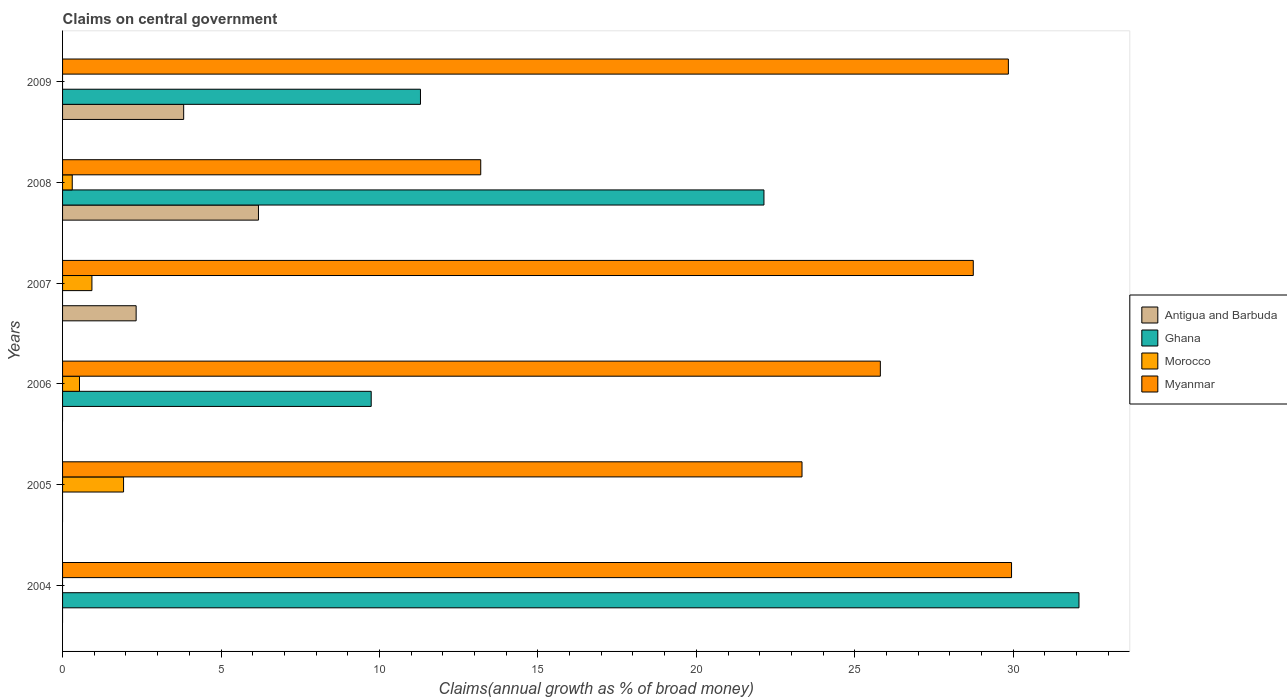How many different coloured bars are there?
Make the answer very short. 4. How many groups of bars are there?
Ensure brevity in your answer.  6. Are the number of bars on each tick of the Y-axis equal?
Your response must be concise. No. How many bars are there on the 5th tick from the top?
Your response must be concise. 2. What is the label of the 1st group of bars from the top?
Your answer should be compact. 2009. In how many cases, is the number of bars for a given year not equal to the number of legend labels?
Your answer should be compact. 5. What is the percentage of broad money claimed on centeral government in Antigua and Barbuda in 2008?
Ensure brevity in your answer.  6.18. Across all years, what is the maximum percentage of broad money claimed on centeral government in Morocco?
Keep it short and to the point. 1.92. Across all years, what is the minimum percentage of broad money claimed on centeral government in Antigua and Barbuda?
Ensure brevity in your answer.  0. In which year was the percentage of broad money claimed on centeral government in Antigua and Barbuda maximum?
Your response must be concise. 2008. What is the total percentage of broad money claimed on centeral government in Morocco in the graph?
Offer a terse response. 3.69. What is the difference between the percentage of broad money claimed on centeral government in Ghana in 2008 and that in 2009?
Give a very brief answer. 10.84. What is the difference between the percentage of broad money claimed on centeral government in Morocco in 2009 and the percentage of broad money claimed on centeral government in Myanmar in 2007?
Provide a succinct answer. -28.74. What is the average percentage of broad money claimed on centeral government in Myanmar per year?
Keep it short and to the point. 25.15. In the year 2008, what is the difference between the percentage of broad money claimed on centeral government in Myanmar and percentage of broad money claimed on centeral government in Ghana?
Provide a short and direct response. -8.94. In how many years, is the percentage of broad money claimed on centeral government in Antigua and Barbuda greater than 3 %?
Provide a short and direct response. 2. What is the ratio of the percentage of broad money claimed on centeral government in Antigua and Barbuda in 2007 to that in 2008?
Ensure brevity in your answer.  0.38. What is the difference between the highest and the second highest percentage of broad money claimed on centeral government in Antigua and Barbuda?
Offer a very short reply. 2.36. What is the difference between the highest and the lowest percentage of broad money claimed on centeral government in Antigua and Barbuda?
Keep it short and to the point. 6.18. Is it the case that in every year, the sum of the percentage of broad money claimed on centeral government in Morocco and percentage of broad money claimed on centeral government in Myanmar is greater than the sum of percentage of broad money claimed on centeral government in Ghana and percentage of broad money claimed on centeral government in Antigua and Barbuda?
Make the answer very short. No. Are all the bars in the graph horizontal?
Offer a very short reply. Yes. How many years are there in the graph?
Offer a very short reply. 6. What is the difference between two consecutive major ticks on the X-axis?
Your response must be concise. 5. Are the values on the major ticks of X-axis written in scientific E-notation?
Keep it short and to the point. No. Does the graph contain any zero values?
Your answer should be compact. Yes. Where does the legend appear in the graph?
Offer a terse response. Center right. How are the legend labels stacked?
Ensure brevity in your answer.  Vertical. What is the title of the graph?
Your answer should be very brief. Claims on central government. What is the label or title of the X-axis?
Your answer should be very brief. Claims(annual growth as % of broad money). What is the Claims(annual growth as % of broad money) in Ghana in 2004?
Offer a very short reply. 32.08. What is the Claims(annual growth as % of broad money) of Myanmar in 2004?
Offer a terse response. 29.95. What is the Claims(annual growth as % of broad money) in Morocco in 2005?
Offer a terse response. 1.92. What is the Claims(annual growth as % of broad money) of Myanmar in 2005?
Ensure brevity in your answer.  23.34. What is the Claims(annual growth as % of broad money) in Antigua and Barbuda in 2006?
Offer a terse response. 0. What is the Claims(annual growth as % of broad money) of Ghana in 2006?
Your answer should be very brief. 9.74. What is the Claims(annual growth as % of broad money) in Morocco in 2006?
Offer a very short reply. 0.53. What is the Claims(annual growth as % of broad money) of Myanmar in 2006?
Keep it short and to the point. 25.81. What is the Claims(annual growth as % of broad money) in Antigua and Barbuda in 2007?
Your answer should be very brief. 2.32. What is the Claims(annual growth as % of broad money) of Morocco in 2007?
Your answer should be very brief. 0.93. What is the Claims(annual growth as % of broad money) of Myanmar in 2007?
Your response must be concise. 28.74. What is the Claims(annual growth as % of broad money) in Antigua and Barbuda in 2008?
Provide a short and direct response. 6.18. What is the Claims(annual growth as % of broad money) of Ghana in 2008?
Your answer should be very brief. 22.13. What is the Claims(annual growth as % of broad money) of Morocco in 2008?
Offer a very short reply. 0.31. What is the Claims(annual growth as % of broad money) of Myanmar in 2008?
Keep it short and to the point. 13.2. What is the Claims(annual growth as % of broad money) of Antigua and Barbuda in 2009?
Offer a terse response. 3.82. What is the Claims(annual growth as % of broad money) of Ghana in 2009?
Keep it short and to the point. 11.29. What is the Claims(annual growth as % of broad money) of Morocco in 2009?
Make the answer very short. 0. What is the Claims(annual growth as % of broad money) in Myanmar in 2009?
Keep it short and to the point. 29.85. Across all years, what is the maximum Claims(annual growth as % of broad money) of Antigua and Barbuda?
Offer a terse response. 6.18. Across all years, what is the maximum Claims(annual growth as % of broad money) in Ghana?
Keep it short and to the point. 32.08. Across all years, what is the maximum Claims(annual growth as % of broad money) of Morocco?
Offer a very short reply. 1.92. Across all years, what is the maximum Claims(annual growth as % of broad money) of Myanmar?
Your answer should be very brief. 29.95. Across all years, what is the minimum Claims(annual growth as % of broad money) of Antigua and Barbuda?
Give a very brief answer. 0. Across all years, what is the minimum Claims(annual growth as % of broad money) in Myanmar?
Your answer should be very brief. 13.2. What is the total Claims(annual growth as % of broad money) in Antigua and Barbuda in the graph?
Provide a short and direct response. 12.33. What is the total Claims(annual growth as % of broad money) of Ghana in the graph?
Ensure brevity in your answer.  75.25. What is the total Claims(annual growth as % of broad money) in Morocco in the graph?
Provide a succinct answer. 3.69. What is the total Claims(annual growth as % of broad money) of Myanmar in the graph?
Provide a short and direct response. 150.88. What is the difference between the Claims(annual growth as % of broad money) in Myanmar in 2004 and that in 2005?
Provide a succinct answer. 6.61. What is the difference between the Claims(annual growth as % of broad money) of Ghana in 2004 and that in 2006?
Your answer should be very brief. 22.34. What is the difference between the Claims(annual growth as % of broad money) of Myanmar in 2004 and that in 2006?
Keep it short and to the point. 4.14. What is the difference between the Claims(annual growth as % of broad money) in Myanmar in 2004 and that in 2007?
Give a very brief answer. 1.21. What is the difference between the Claims(annual growth as % of broad money) of Ghana in 2004 and that in 2008?
Your response must be concise. 9.94. What is the difference between the Claims(annual growth as % of broad money) in Myanmar in 2004 and that in 2008?
Offer a terse response. 16.75. What is the difference between the Claims(annual growth as % of broad money) in Ghana in 2004 and that in 2009?
Give a very brief answer. 20.78. What is the difference between the Claims(annual growth as % of broad money) of Myanmar in 2004 and that in 2009?
Ensure brevity in your answer.  0.1. What is the difference between the Claims(annual growth as % of broad money) of Morocco in 2005 and that in 2006?
Offer a terse response. 1.39. What is the difference between the Claims(annual growth as % of broad money) of Myanmar in 2005 and that in 2006?
Make the answer very short. -2.47. What is the difference between the Claims(annual growth as % of broad money) of Myanmar in 2005 and that in 2007?
Keep it short and to the point. -5.41. What is the difference between the Claims(annual growth as % of broad money) of Morocco in 2005 and that in 2008?
Your response must be concise. 1.62. What is the difference between the Claims(annual growth as % of broad money) in Myanmar in 2005 and that in 2008?
Give a very brief answer. 10.14. What is the difference between the Claims(annual growth as % of broad money) of Myanmar in 2005 and that in 2009?
Your answer should be compact. -6.51. What is the difference between the Claims(annual growth as % of broad money) in Morocco in 2006 and that in 2007?
Offer a very short reply. -0.39. What is the difference between the Claims(annual growth as % of broad money) in Myanmar in 2006 and that in 2007?
Your answer should be compact. -2.93. What is the difference between the Claims(annual growth as % of broad money) in Ghana in 2006 and that in 2008?
Your answer should be very brief. -12.39. What is the difference between the Claims(annual growth as % of broad money) in Morocco in 2006 and that in 2008?
Offer a terse response. 0.23. What is the difference between the Claims(annual growth as % of broad money) of Myanmar in 2006 and that in 2008?
Keep it short and to the point. 12.61. What is the difference between the Claims(annual growth as % of broad money) of Ghana in 2006 and that in 2009?
Keep it short and to the point. -1.55. What is the difference between the Claims(annual growth as % of broad money) of Myanmar in 2006 and that in 2009?
Offer a terse response. -4.04. What is the difference between the Claims(annual growth as % of broad money) in Antigua and Barbuda in 2007 and that in 2008?
Your answer should be compact. -3.86. What is the difference between the Claims(annual growth as % of broad money) in Morocco in 2007 and that in 2008?
Your response must be concise. 0.62. What is the difference between the Claims(annual growth as % of broad money) in Myanmar in 2007 and that in 2008?
Ensure brevity in your answer.  15.54. What is the difference between the Claims(annual growth as % of broad money) of Myanmar in 2007 and that in 2009?
Provide a short and direct response. -1.11. What is the difference between the Claims(annual growth as % of broad money) of Antigua and Barbuda in 2008 and that in 2009?
Make the answer very short. 2.36. What is the difference between the Claims(annual growth as % of broad money) in Ghana in 2008 and that in 2009?
Provide a short and direct response. 10.84. What is the difference between the Claims(annual growth as % of broad money) of Myanmar in 2008 and that in 2009?
Your response must be concise. -16.65. What is the difference between the Claims(annual growth as % of broad money) of Ghana in 2004 and the Claims(annual growth as % of broad money) of Morocco in 2005?
Make the answer very short. 30.15. What is the difference between the Claims(annual growth as % of broad money) in Ghana in 2004 and the Claims(annual growth as % of broad money) in Myanmar in 2005?
Provide a succinct answer. 8.74. What is the difference between the Claims(annual growth as % of broad money) of Ghana in 2004 and the Claims(annual growth as % of broad money) of Morocco in 2006?
Ensure brevity in your answer.  31.54. What is the difference between the Claims(annual growth as % of broad money) of Ghana in 2004 and the Claims(annual growth as % of broad money) of Myanmar in 2006?
Provide a short and direct response. 6.27. What is the difference between the Claims(annual growth as % of broad money) in Ghana in 2004 and the Claims(annual growth as % of broad money) in Morocco in 2007?
Offer a very short reply. 31.15. What is the difference between the Claims(annual growth as % of broad money) of Ghana in 2004 and the Claims(annual growth as % of broad money) of Myanmar in 2007?
Keep it short and to the point. 3.34. What is the difference between the Claims(annual growth as % of broad money) in Ghana in 2004 and the Claims(annual growth as % of broad money) in Morocco in 2008?
Provide a short and direct response. 31.77. What is the difference between the Claims(annual growth as % of broad money) of Ghana in 2004 and the Claims(annual growth as % of broad money) of Myanmar in 2008?
Provide a succinct answer. 18.88. What is the difference between the Claims(annual growth as % of broad money) in Ghana in 2004 and the Claims(annual growth as % of broad money) in Myanmar in 2009?
Your answer should be compact. 2.23. What is the difference between the Claims(annual growth as % of broad money) in Morocco in 2005 and the Claims(annual growth as % of broad money) in Myanmar in 2006?
Make the answer very short. -23.88. What is the difference between the Claims(annual growth as % of broad money) in Morocco in 2005 and the Claims(annual growth as % of broad money) in Myanmar in 2007?
Give a very brief answer. -26.82. What is the difference between the Claims(annual growth as % of broad money) in Morocco in 2005 and the Claims(annual growth as % of broad money) in Myanmar in 2008?
Give a very brief answer. -11.27. What is the difference between the Claims(annual growth as % of broad money) of Morocco in 2005 and the Claims(annual growth as % of broad money) of Myanmar in 2009?
Provide a succinct answer. -27.92. What is the difference between the Claims(annual growth as % of broad money) of Ghana in 2006 and the Claims(annual growth as % of broad money) of Morocco in 2007?
Ensure brevity in your answer.  8.81. What is the difference between the Claims(annual growth as % of broad money) in Ghana in 2006 and the Claims(annual growth as % of broad money) in Myanmar in 2007?
Make the answer very short. -19. What is the difference between the Claims(annual growth as % of broad money) of Morocco in 2006 and the Claims(annual growth as % of broad money) of Myanmar in 2007?
Give a very brief answer. -28.21. What is the difference between the Claims(annual growth as % of broad money) in Ghana in 2006 and the Claims(annual growth as % of broad money) in Morocco in 2008?
Offer a very short reply. 9.43. What is the difference between the Claims(annual growth as % of broad money) of Ghana in 2006 and the Claims(annual growth as % of broad money) of Myanmar in 2008?
Your answer should be compact. -3.46. What is the difference between the Claims(annual growth as % of broad money) in Morocco in 2006 and the Claims(annual growth as % of broad money) in Myanmar in 2008?
Keep it short and to the point. -12.66. What is the difference between the Claims(annual growth as % of broad money) of Ghana in 2006 and the Claims(annual growth as % of broad money) of Myanmar in 2009?
Your response must be concise. -20.11. What is the difference between the Claims(annual growth as % of broad money) of Morocco in 2006 and the Claims(annual growth as % of broad money) of Myanmar in 2009?
Give a very brief answer. -29.31. What is the difference between the Claims(annual growth as % of broad money) in Antigua and Barbuda in 2007 and the Claims(annual growth as % of broad money) in Ghana in 2008?
Keep it short and to the point. -19.81. What is the difference between the Claims(annual growth as % of broad money) of Antigua and Barbuda in 2007 and the Claims(annual growth as % of broad money) of Morocco in 2008?
Your answer should be very brief. 2.02. What is the difference between the Claims(annual growth as % of broad money) in Antigua and Barbuda in 2007 and the Claims(annual growth as % of broad money) in Myanmar in 2008?
Offer a very short reply. -10.87. What is the difference between the Claims(annual growth as % of broad money) in Morocco in 2007 and the Claims(annual growth as % of broad money) in Myanmar in 2008?
Offer a very short reply. -12.27. What is the difference between the Claims(annual growth as % of broad money) of Antigua and Barbuda in 2007 and the Claims(annual growth as % of broad money) of Ghana in 2009?
Offer a terse response. -8.97. What is the difference between the Claims(annual growth as % of broad money) of Antigua and Barbuda in 2007 and the Claims(annual growth as % of broad money) of Myanmar in 2009?
Offer a terse response. -27.53. What is the difference between the Claims(annual growth as % of broad money) of Morocco in 2007 and the Claims(annual growth as % of broad money) of Myanmar in 2009?
Keep it short and to the point. -28.92. What is the difference between the Claims(annual growth as % of broad money) of Antigua and Barbuda in 2008 and the Claims(annual growth as % of broad money) of Ghana in 2009?
Ensure brevity in your answer.  -5.11. What is the difference between the Claims(annual growth as % of broad money) of Antigua and Barbuda in 2008 and the Claims(annual growth as % of broad money) of Myanmar in 2009?
Make the answer very short. -23.67. What is the difference between the Claims(annual growth as % of broad money) in Ghana in 2008 and the Claims(annual growth as % of broad money) in Myanmar in 2009?
Your answer should be very brief. -7.71. What is the difference between the Claims(annual growth as % of broad money) in Morocco in 2008 and the Claims(annual growth as % of broad money) in Myanmar in 2009?
Keep it short and to the point. -29.54. What is the average Claims(annual growth as % of broad money) of Antigua and Barbuda per year?
Your answer should be compact. 2.05. What is the average Claims(annual growth as % of broad money) in Ghana per year?
Provide a succinct answer. 12.54. What is the average Claims(annual growth as % of broad money) of Morocco per year?
Your answer should be compact. 0.62. What is the average Claims(annual growth as % of broad money) in Myanmar per year?
Provide a short and direct response. 25.15. In the year 2004, what is the difference between the Claims(annual growth as % of broad money) in Ghana and Claims(annual growth as % of broad money) in Myanmar?
Your answer should be very brief. 2.13. In the year 2005, what is the difference between the Claims(annual growth as % of broad money) of Morocco and Claims(annual growth as % of broad money) of Myanmar?
Your response must be concise. -21.41. In the year 2006, what is the difference between the Claims(annual growth as % of broad money) of Ghana and Claims(annual growth as % of broad money) of Morocco?
Make the answer very short. 9.21. In the year 2006, what is the difference between the Claims(annual growth as % of broad money) in Ghana and Claims(annual growth as % of broad money) in Myanmar?
Your response must be concise. -16.07. In the year 2006, what is the difference between the Claims(annual growth as % of broad money) of Morocco and Claims(annual growth as % of broad money) of Myanmar?
Give a very brief answer. -25.27. In the year 2007, what is the difference between the Claims(annual growth as % of broad money) in Antigua and Barbuda and Claims(annual growth as % of broad money) in Morocco?
Your answer should be very brief. 1.4. In the year 2007, what is the difference between the Claims(annual growth as % of broad money) in Antigua and Barbuda and Claims(annual growth as % of broad money) in Myanmar?
Offer a terse response. -26.42. In the year 2007, what is the difference between the Claims(annual growth as % of broad money) in Morocco and Claims(annual growth as % of broad money) in Myanmar?
Offer a very short reply. -27.81. In the year 2008, what is the difference between the Claims(annual growth as % of broad money) of Antigua and Barbuda and Claims(annual growth as % of broad money) of Ghana?
Keep it short and to the point. -15.95. In the year 2008, what is the difference between the Claims(annual growth as % of broad money) of Antigua and Barbuda and Claims(annual growth as % of broad money) of Morocco?
Give a very brief answer. 5.88. In the year 2008, what is the difference between the Claims(annual growth as % of broad money) of Antigua and Barbuda and Claims(annual growth as % of broad money) of Myanmar?
Offer a very short reply. -7.01. In the year 2008, what is the difference between the Claims(annual growth as % of broad money) of Ghana and Claims(annual growth as % of broad money) of Morocco?
Keep it short and to the point. 21.83. In the year 2008, what is the difference between the Claims(annual growth as % of broad money) in Ghana and Claims(annual growth as % of broad money) in Myanmar?
Your answer should be compact. 8.94. In the year 2008, what is the difference between the Claims(annual growth as % of broad money) of Morocco and Claims(annual growth as % of broad money) of Myanmar?
Provide a short and direct response. -12.89. In the year 2009, what is the difference between the Claims(annual growth as % of broad money) of Antigua and Barbuda and Claims(annual growth as % of broad money) of Ghana?
Ensure brevity in your answer.  -7.47. In the year 2009, what is the difference between the Claims(annual growth as % of broad money) in Antigua and Barbuda and Claims(annual growth as % of broad money) in Myanmar?
Provide a short and direct response. -26.03. In the year 2009, what is the difference between the Claims(annual growth as % of broad money) in Ghana and Claims(annual growth as % of broad money) in Myanmar?
Keep it short and to the point. -18.55. What is the ratio of the Claims(annual growth as % of broad money) of Myanmar in 2004 to that in 2005?
Offer a very short reply. 1.28. What is the ratio of the Claims(annual growth as % of broad money) in Ghana in 2004 to that in 2006?
Provide a succinct answer. 3.29. What is the ratio of the Claims(annual growth as % of broad money) in Myanmar in 2004 to that in 2006?
Provide a short and direct response. 1.16. What is the ratio of the Claims(annual growth as % of broad money) of Myanmar in 2004 to that in 2007?
Your answer should be compact. 1.04. What is the ratio of the Claims(annual growth as % of broad money) in Ghana in 2004 to that in 2008?
Provide a succinct answer. 1.45. What is the ratio of the Claims(annual growth as % of broad money) of Myanmar in 2004 to that in 2008?
Offer a very short reply. 2.27. What is the ratio of the Claims(annual growth as % of broad money) of Ghana in 2004 to that in 2009?
Ensure brevity in your answer.  2.84. What is the ratio of the Claims(annual growth as % of broad money) of Morocco in 2005 to that in 2006?
Your answer should be compact. 3.61. What is the ratio of the Claims(annual growth as % of broad money) of Myanmar in 2005 to that in 2006?
Your answer should be compact. 0.9. What is the ratio of the Claims(annual growth as % of broad money) in Morocco in 2005 to that in 2007?
Your response must be concise. 2.08. What is the ratio of the Claims(annual growth as % of broad money) in Myanmar in 2005 to that in 2007?
Ensure brevity in your answer.  0.81. What is the ratio of the Claims(annual growth as % of broad money) in Morocco in 2005 to that in 2008?
Your response must be concise. 6.29. What is the ratio of the Claims(annual growth as % of broad money) of Myanmar in 2005 to that in 2008?
Provide a short and direct response. 1.77. What is the ratio of the Claims(annual growth as % of broad money) in Myanmar in 2005 to that in 2009?
Provide a succinct answer. 0.78. What is the ratio of the Claims(annual growth as % of broad money) of Morocco in 2006 to that in 2007?
Your response must be concise. 0.58. What is the ratio of the Claims(annual growth as % of broad money) in Myanmar in 2006 to that in 2007?
Your answer should be compact. 0.9. What is the ratio of the Claims(annual growth as % of broad money) of Ghana in 2006 to that in 2008?
Offer a very short reply. 0.44. What is the ratio of the Claims(annual growth as % of broad money) of Morocco in 2006 to that in 2008?
Ensure brevity in your answer.  1.74. What is the ratio of the Claims(annual growth as % of broad money) of Myanmar in 2006 to that in 2008?
Give a very brief answer. 1.96. What is the ratio of the Claims(annual growth as % of broad money) of Ghana in 2006 to that in 2009?
Keep it short and to the point. 0.86. What is the ratio of the Claims(annual growth as % of broad money) of Myanmar in 2006 to that in 2009?
Your response must be concise. 0.86. What is the ratio of the Claims(annual growth as % of broad money) of Antigua and Barbuda in 2007 to that in 2008?
Offer a very short reply. 0.38. What is the ratio of the Claims(annual growth as % of broad money) in Morocco in 2007 to that in 2008?
Provide a succinct answer. 3.03. What is the ratio of the Claims(annual growth as % of broad money) in Myanmar in 2007 to that in 2008?
Offer a terse response. 2.18. What is the ratio of the Claims(annual growth as % of broad money) in Antigua and Barbuda in 2007 to that in 2009?
Provide a succinct answer. 0.61. What is the ratio of the Claims(annual growth as % of broad money) of Myanmar in 2007 to that in 2009?
Your answer should be very brief. 0.96. What is the ratio of the Claims(annual growth as % of broad money) of Antigua and Barbuda in 2008 to that in 2009?
Give a very brief answer. 1.62. What is the ratio of the Claims(annual growth as % of broad money) of Ghana in 2008 to that in 2009?
Offer a very short reply. 1.96. What is the ratio of the Claims(annual growth as % of broad money) of Myanmar in 2008 to that in 2009?
Your answer should be compact. 0.44. What is the difference between the highest and the second highest Claims(annual growth as % of broad money) in Antigua and Barbuda?
Your answer should be very brief. 2.36. What is the difference between the highest and the second highest Claims(annual growth as % of broad money) in Ghana?
Your response must be concise. 9.94. What is the difference between the highest and the second highest Claims(annual growth as % of broad money) of Morocco?
Your answer should be compact. 1. What is the difference between the highest and the second highest Claims(annual growth as % of broad money) of Myanmar?
Your answer should be compact. 0.1. What is the difference between the highest and the lowest Claims(annual growth as % of broad money) in Antigua and Barbuda?
Your answer should be very brief. 6.18. What is the difference between the highest and the lowest Claims(annual growth as % of broad money) of Ghana?
Provide a succinct answer. 32.08. What is the difference between the highest and the lowest Claims(annual growth as % of broad money) of Morocco?
Give a very brief answer. 1.92. What is the difference between the highest and the lowest Claims(annual growth as % of broad money) in Myanmar?
Your response must be concise. 16.75. 